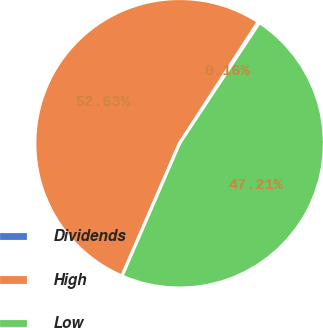Convert chart. <chart><loc_0><loc_0><loc_500><loc_500><pie_chart><fcel>Dividends<fcel>High<fcel>Low<nl><fcel>0.16%<fcel>52.62%<fcel>47.21%<nl></chart> 